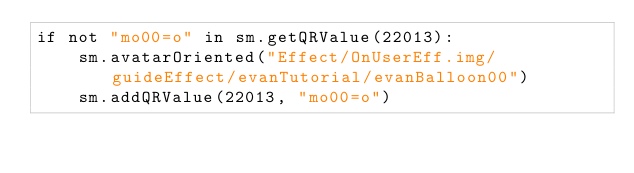Convert code to text. <code><loc_0><loc_0><loc_500><loc_500><_Python_>if not "mo00=o" in sm.getQRValue(22013):
    sm.avatarOriented("Effect/OnUserEff.img/guideEffect/evanTutorial/evanBalloon00")
    sm.addQRValue(22013, "mo00=o")</code> 